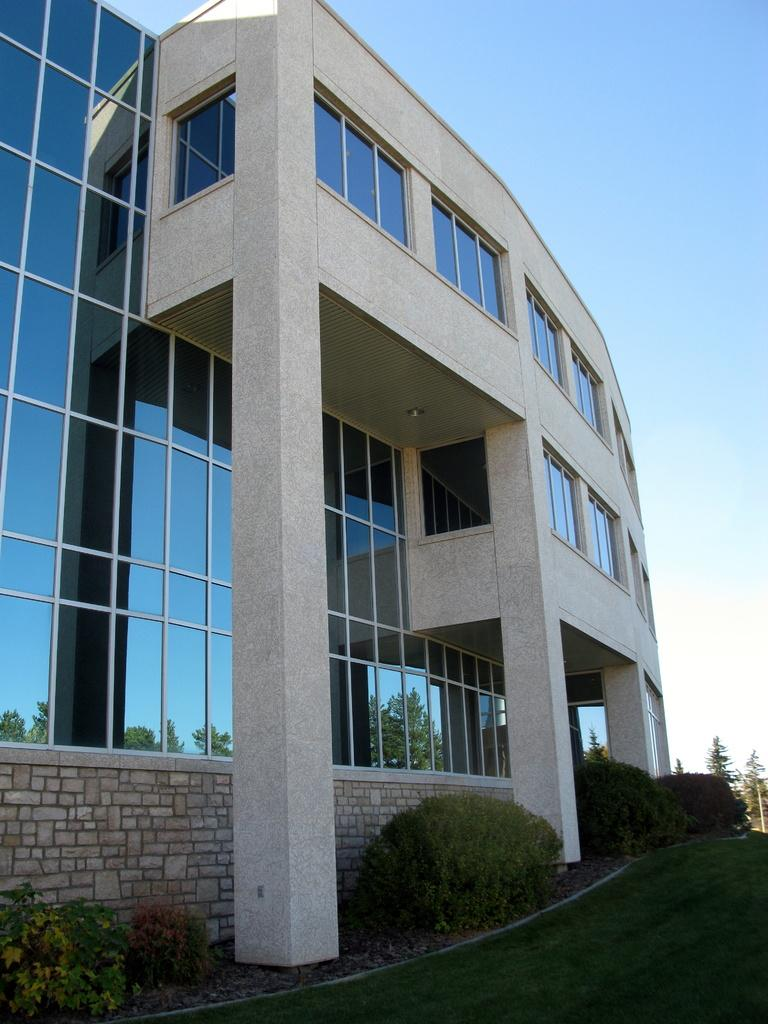What type of building is in the image? There is a big glass building with pillars in the image. Is there anything attached to the building? Yes, there is an object attached to the building. What type of vegetation can be seen in the image? There are trees, plants, and grass in the image. What is visible in the background of the image? The sky is visible in the background of the image. Can you see a spoon being used to eat in the image? There is no spoon or any eating activity visible in the image. Are there any deer present in the image? There are no deer present in the image. 